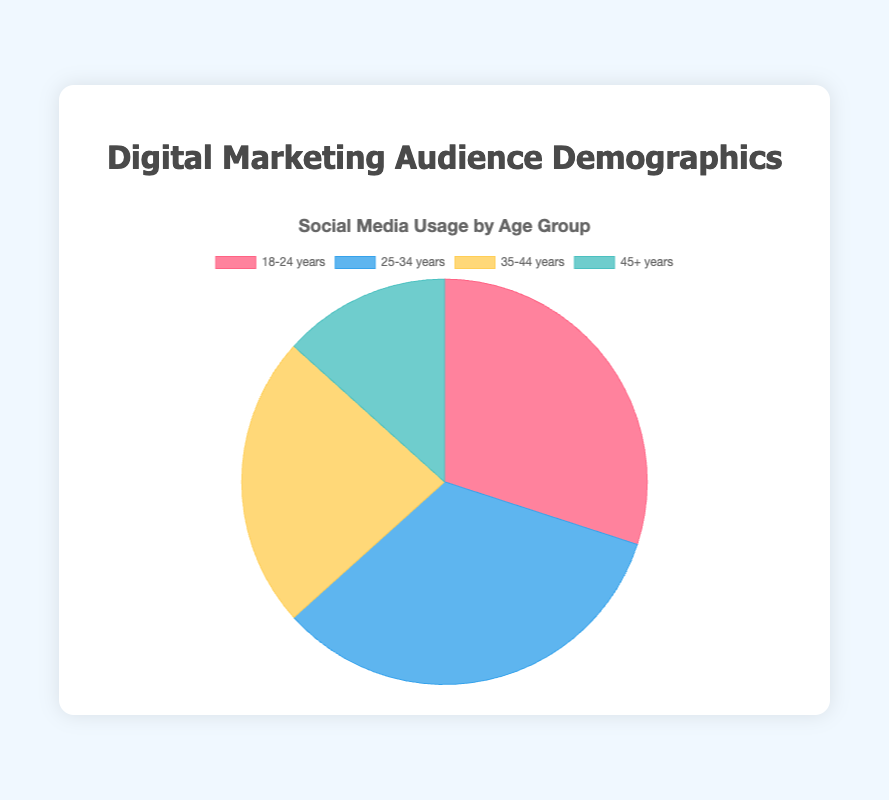Which age group has the highest percentage of social media usage? According to the pie chart, the 25-34 years age group has the highest percentage of social media usage, which is 50%.
Answer: 25-34 years Which age group uses social media the least? The chart indicates that the 45+ years age group uses social media the least, with a usage rate of 20%.
Answer: 45+ years What is the combined percentage of social media usage for the 18-24 years and 35-44 years age groups? The percentage of social media usage for the 18-24 years group is 45%, and for the 35-44 years group is 35%. Adding these together gives 45% + 35% = 80%.
Answer: 80% By how much does the social media usage of the 25-34 years age group surpass that of the 45+ years age group? The social media usage of the 25-34 years age group is 50%, while for the 45+ years age group it is 20%. The difference is 50% - 20% = 30%.
Answer: 30% What is the average social media usage across all age groups? Sum the percentages: 45% (18-24) + 50% (25-34) + 35% (35-44) + 20% (45+). The total is 150%. Dividing by 4 gives the average: 150% / 4 = 37.5%.
Answer: 37.5% Which color represents the 18-24 years age group in the pie chart? The color corresponding to the 18-24 years age group is red.
Answer: red If you combined the social media usage of the 18-24 years and 25-34 years groups, what percentage of the total would they constitute? The percentage for the 18-24 years group is 45%, and for the 25-34 years group is 50%. Together, they make up 45% + 50% = 95% of the total.
Answer: 95% By what percentage does the social media usage of the 35-44 years age group exceed that of the 45+ years age group? The social media usage of the 35-44 years group is 35% and that of the 45+ years group is 20%. The difference calculated as a percentage is (35 - 20)/20 * 100% = 75%.
Answer: 75% Which two age groups have the closest social media usage rates? The 18-24 years group has a usage rate of 45%, and the 25-34 years group has a rate of 50%. The difference between them is 5%, which is the smallest compared to the differences between other groups.
Answer: 18-24 years and 25-34 years 